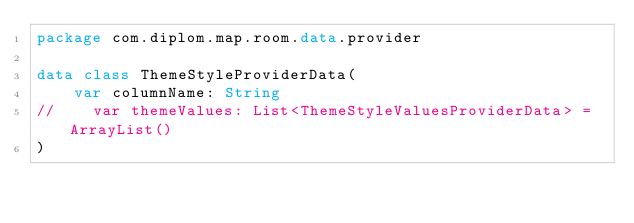<code> <loc_0><loc_0><loc_500><loc_500><_Kotlin_>package com.diplom.map.room.data.provider

data class ThemeStyleProviderData(
    var columnName: String
//    var themeValues: List<ThemeStyleValuesProviderData> = ArrayList()
)</code> 